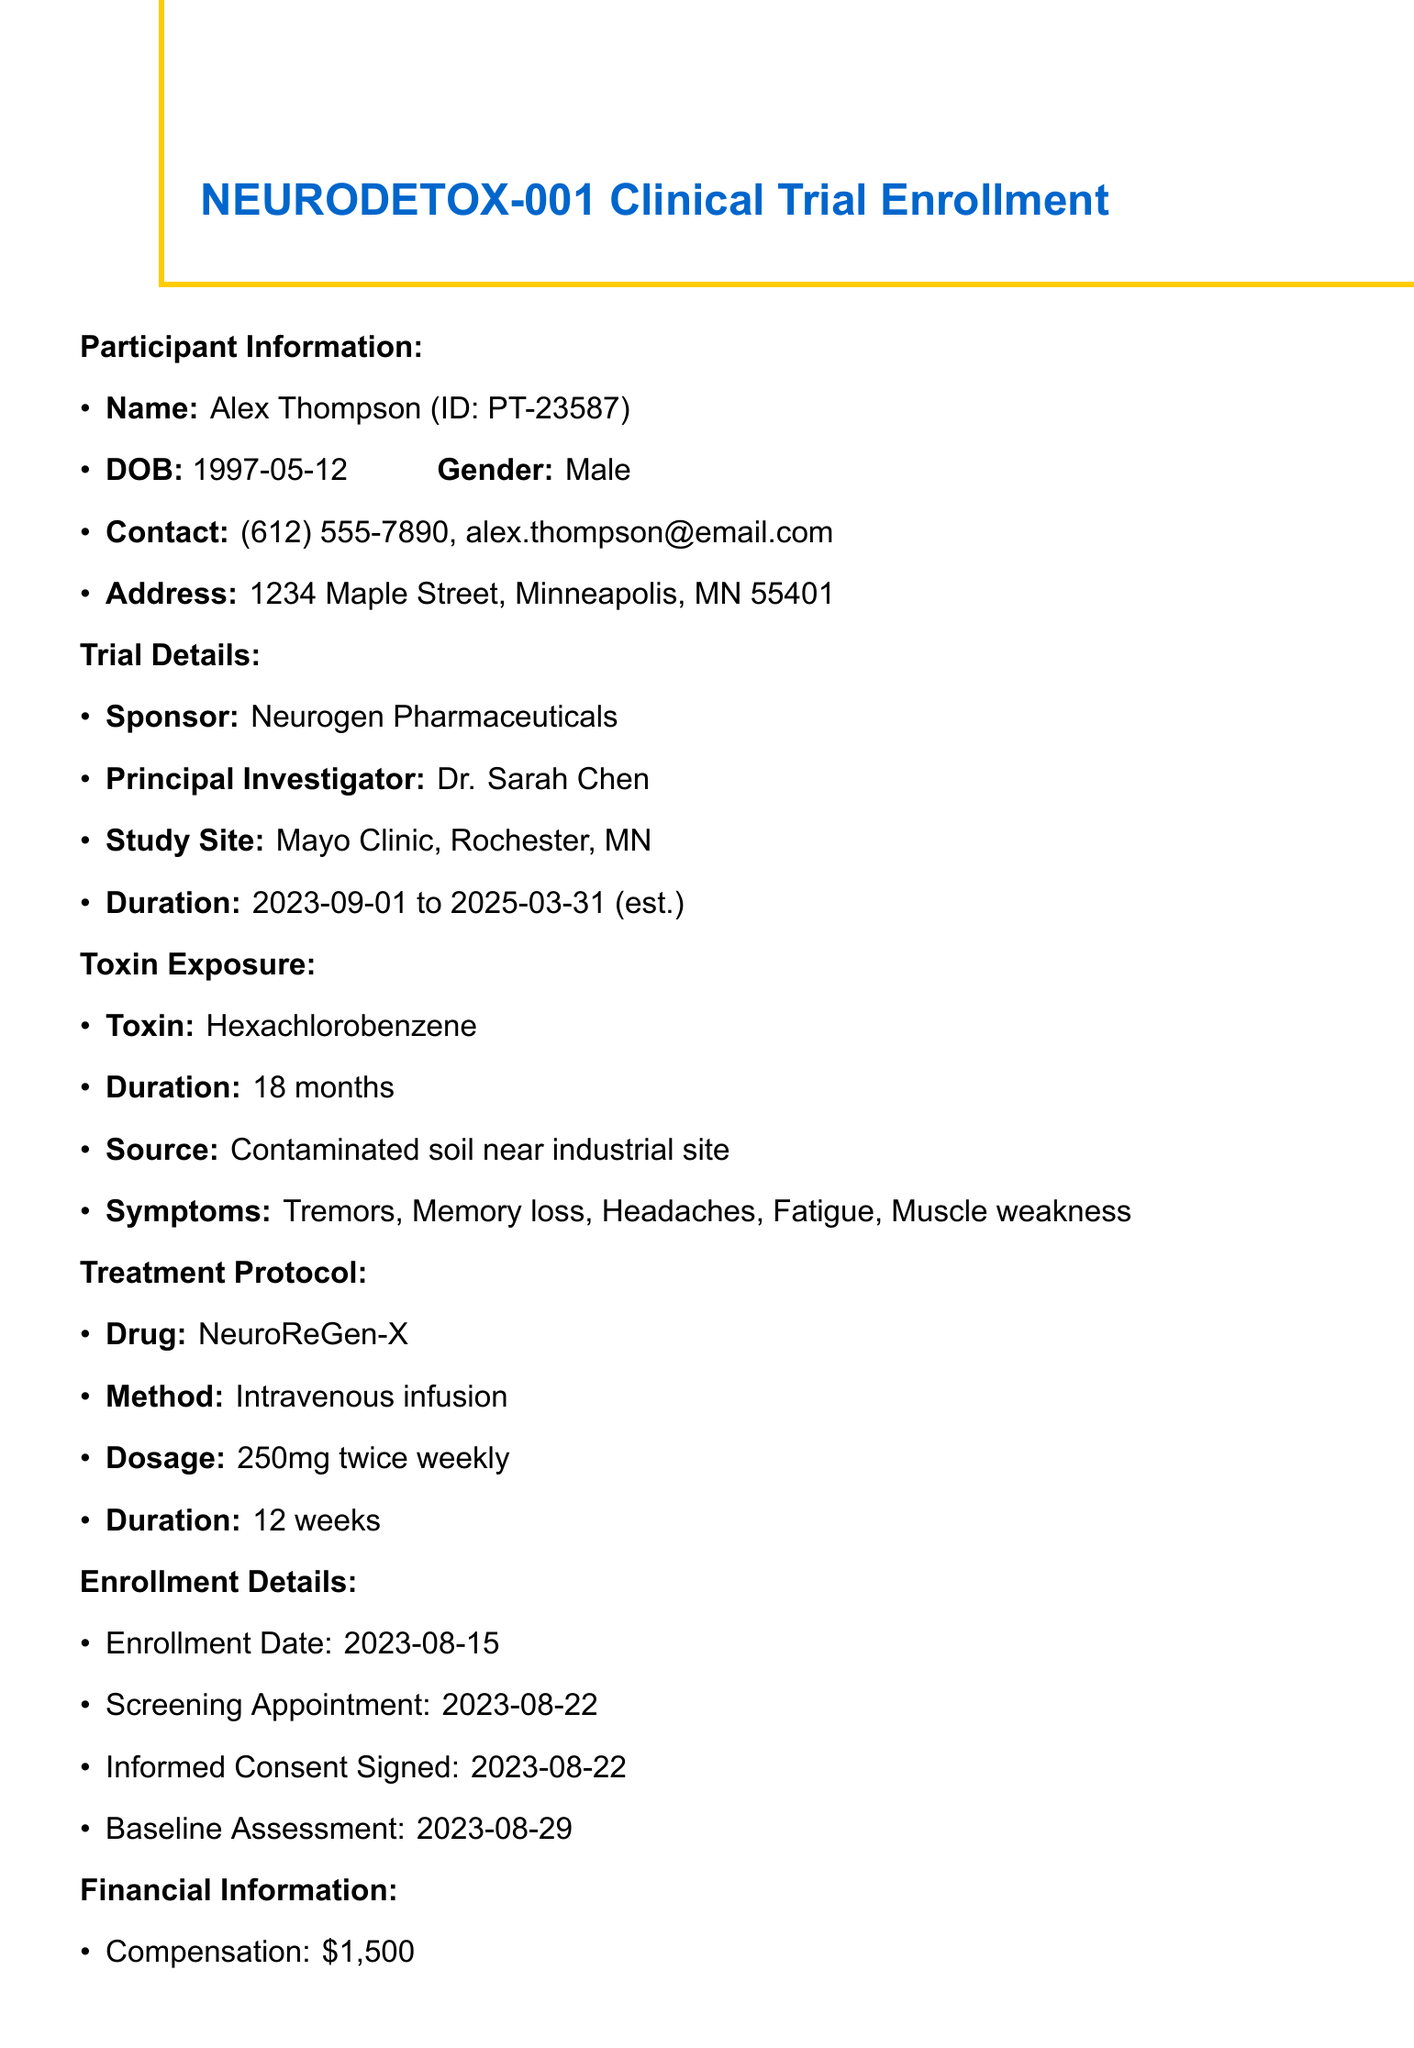What is the trial name? The trial name is stated in the clinical trial section of the document.
Answer: NEURODETOX-001 Who is the principal investigator? The principal investigator is mentioned under trial details.
Answer: Dr. Sarah Chen What is the exposure duration to the toxin? The exposure duration is provided in the toxin exposure section.
Answer: 18 months When is the post-treatment assessment scheduled? The post-treatment assessment date is listed in the follow-up schedule.
Answer: 2023-11-28 How much is the participation compensation? The participation compensation is detailed in the financial information section.
Answer: $1,500 What is the treatment duration for the experimental drug? The treatment duration is found in the treatment protocol section of the document.
Answer: 12 weeks Where was the toxin exposure sourced from? The source of the toxin exposure is specified in the toxin exposure section.
Answer: Contaminated soil near industrial site How many follow-up visits are scheduled after treatment? The follow-up schedule outlines the number of visits planned.
Answer: Three What assessments are required before treatment? The required assessments are listed in a separate section of the document.
Answer: Blood tests, MRI scans, Cognitive function tests, Quality of life questionnaires, Neurological examinations 